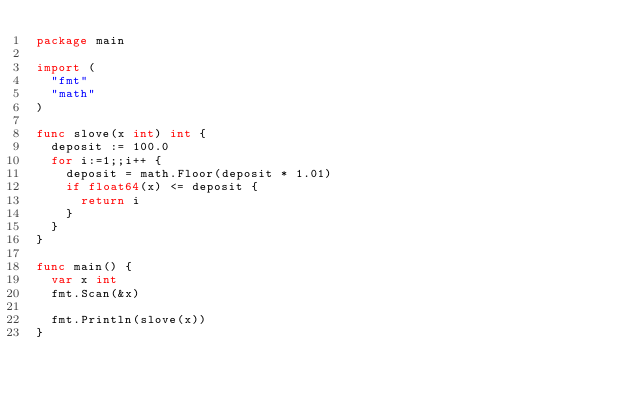Convert code to text. <code><loc_0><loc_0><loc_500><loc_500><_Go_>package main

import (
  "fmt"
  "math"
)

func slove(x int) int {
  deposit := 100.0
  for i:=1;;i++ {
    deposit = math.Floor(deposit * 1.01)
    if float64(x) <= deposit {
      return i
    }
  }
}

func main() {
  var x int
  fmt.Scan(&x)
  
  fmt.Println(slove(x))
}</code> 